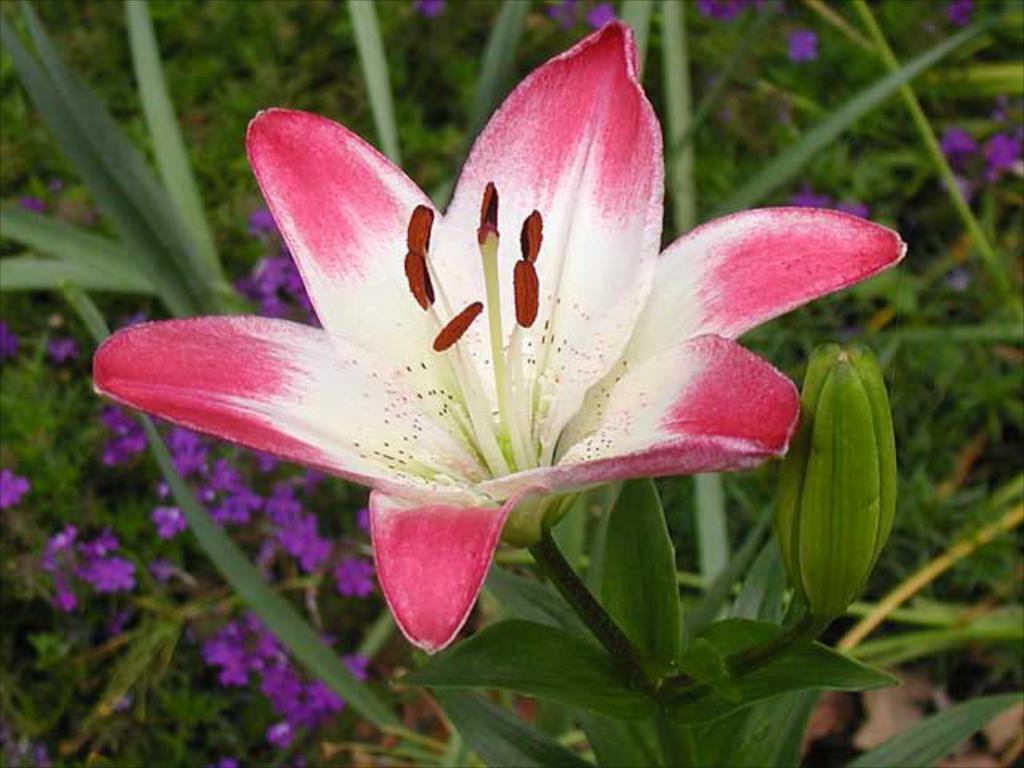Can you describe this image briefly? In the image there is a stem with leaves, bud and flower which is in white and pink color. In the background there are leaves and violet color flowers. 